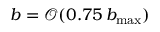<formula> <loc_0><loc_0><loc_500><loc_500>b = \mathcal { O } ( 0 . 7 5 \, b _ { \max } )</formula> 